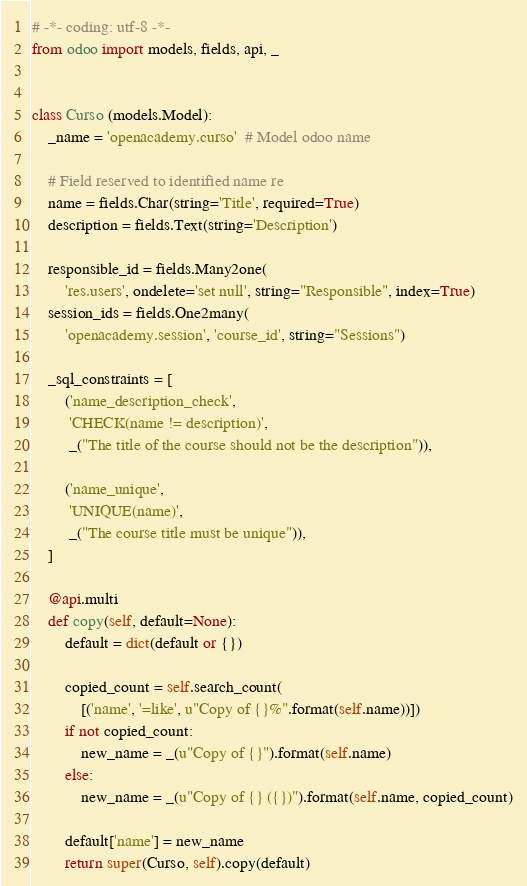Convert code to text. <code><loc_0><loc_0><loc_500><loc_500><_Python_># -*- coding: utf-8 -*-
from odoo import models, fields, api, _


class Curso (models.Model):
    _name = 'openacademy.curso'  # Model odoo name

    # Field reserved to identified name re
    name = fields.Char(string='Title', required=True)
    description = fields.Text(string='Description')

    responsible_id = fields.Many2one(
        'res.users', ondelete='set null', string="Responsible", index=True)
    session_ids = fields.One2many(
        'openacademy.session', 'course_id', string="Sessions")

    _sql_constraints = [
        ('name_description_check',
         'CHECK(name != description)',
         _("The title of the course should not be the description")),

        ('name_unique',
         'UNIQUE(name)',
         _("The course title must be unique")),
    ]
    
    @api.multi
    def copy(self, default=None):
        default = dict(default or {})

        copied_count = self.search_count(
            [('name', '=like', u"Copy of {}%".format(self.name))])
        if not copied_count:
            new_name = _(u"Copy of {}").format(self.name)
        else:
            new_name = _(u"Copy of {} ({})").format(self.name, copied_count)

        default['name'] = new_name
        return super(Curso, self).copy(default)
</code> 